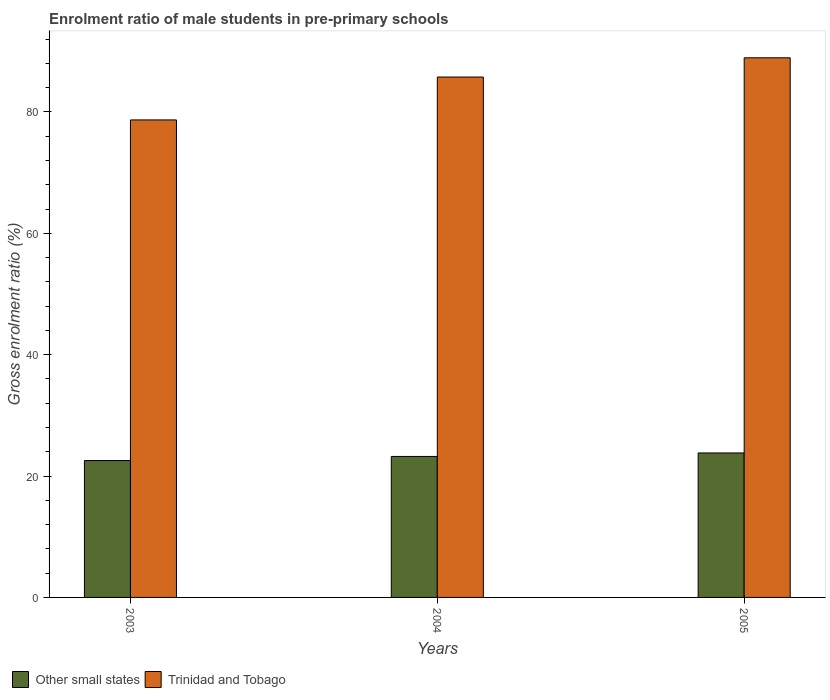How many different coloured bars are there?
Give a very brief answer. 2. Are the number of bars on each tick of the X-axis equal?
Offer a terse response. Yes. How many bars are there on the 2nd tick from the right?
Offer a terse response. 2. What is the label of the 1st group of bars from the left?
Offer a terse response. 2003. In how many cases, is the number of bars for a given year not equal to the number of legend labels?
Your answer should be compact. 0. What is the enrolment ratio of male students in pre-primary schools in Trinidad and Tobago in 2003?
Provide a succinct answer. 78.69. Across all years, what is the maximum enrolment ratio of male students in pre-primary schools in Trinidad and Tobago?
Offer a terse response. 88.92. Across all years, what is the minimum enrolment ratio of male students in pre-primary schools in Trinidad and Tobago?
Make the answer very short. 78.69. In which year was the enrolment ratio of male students in pre-primary schools in Other small states maximum?
Offer a terse response. 2005. What is the total enrolment ratio of male students in pre-primary schools in Other small states in the graph?
Offer a very short reply. 69.6. What is the difference between the enrolment ratio of male students in pre-primary schools in Trinidad and Tobago in 2003 and that in 2005?
Provide a succinct answer. -10.24. What is the difference between the enrolment ratio of male students in pre-primary schools in Trinidad and Tobago in 2003 and the enrolment ratio of male students in pre-primary schools in Other small states in 2005?
Give a very brief answer. 54.88. What is the average enrolment ratio of male students in pre-primary schools in Trinidad and Tobago per year?
Make the answer very short. 84.46. In the year 2005, what is the difference between the enrolment ratio of male students in pre-primary schools in Trinidad and Tobago and enrolment ratio of male students in pre-primary schools in Other small states?
Your answer should be compact. 65.11. What is the ratio of the enrolment ratio of male students in pre-primary schools in Trinidad and Tobago in 2004 to that in 2005?
Your response must be concise. 0.96. What is the difference between the highest and the second highest enrolment ratio of male students in pre-primary schools in Trinidad and Tobago?
Keep it short and to the point. 3.17. What is the difference between the highest and the lowest enrolment ratio of male students in pre-primary schools in Trinidad and Tobago?
Your response must be concise. 10.24. What does the 1st bar from the left in 2003 represents?
Make the answer very short. Other small states. What does the 1st bar from the right in 2005 represents?
Provide a succinct answer. Trinidad and Tobago. Are all the bars in the graph horizontal?
Keep it short and to the point. No. How many years are there in the graph?
Ensure brevity in your answer.  3. Are the values on the major ticks of Y-axis written in scientific E-notation?
Give a very brief answer. No. Does the graph contain any zero values?
Provide a short and direct response. No. Where does the legend appear in the graph?
Provide a succinct answer. Bottom left. What is the title of the graph?
Keep it short and to the point. Enrolment ratio of male students in pre-primary schools. What is the Gross enrolment ratio (%) of Other small states in 2003?
Your answer should be compact. 22.55. What is the Gross enrolment ratio (%) of Trinidad and Tobago in 2003?
Your response must be concise. 78.69. What is the Gross enrolment ratio (%) of Other small states in 2004?
Your response must be concise. 23.23. What is the Gross enrolment ratio (%) in Trinidad and Tobago in 2004?
Your answer should be compact. 85.75. What is the Gross enrolment ratio (%) of Other small states in 2005?
Offer a very short reply. 23.81. What is the Gross enrolment ratio (%) of Trinidad and Tobago in 2005?
Your answer should be compact. 88.92. Across all years, what is the maximum Gross enrolment ratio (%) of Other small states?
Offer a very short reply. 23.81. Across all years, what is the maximum Gross enrolment ratio (%) of Trinidad and Tobago?
Ensure brevity in your answer.  88.92. Across all years, what is the minimum Gross enrolment ratio (%) in Other small states?
Provide a succinct answer. 22.55. Across all years, what is the minimum Gross enrolment ratio (%) in Trinidad and Tobago?
Keep it short and to the point. 78.69. What is the total Gross enrolment ratio (%) in Other small states in the graph?
Give a very brief answer. 69.6. What is the total Gross enrolment ratio (%) in Trinidad and Tobago in the graph?
Provide a succinct answer. 253.37. What is the difference between the Gross enrolment ratio (%) in Other small states in 2003 and that in 2004?
Your response must be concise. -0.68. What is the difference between the Gross enrolment ratio (%) in Trinidad and Tobago in 2003 and that in 2004?
Provide a short and direct response. -7.07. What is the difference between the Gross enrolment ratio (%) in Other small states in 2003 and that in 2005?
Keep it short and to the point. -1.25. What is the difference between the Gross enrolment ratio (%) in Trinidad and Tobago in 2003 and that in 2005?
Make the answer very short. -10.24. What is the difference between the Gross enrolment ratio (%) of Other small states in 2004 and that in 2005?
Offer a terse response. -0.58. What is the difference between the Gross enrolment ratio (%) in Trinidad and Tobago in 2004 and that in 2005?
Offer a very short reply. -3.17. What is the difference between the Gross enrolment ratio (%) in Other small states in 2003 and the Gross enrolment ratio (%) in Trinidad and Tobago in 2004?
Provide a short and direct response. -63.2. What is the difference between the Gross enrolment ratio (%) in Other small states in 2003 and the Gross enrolment ratio (%) in Trinidad and Tobago in 2005?
Your response must be concise. -66.37. What is the difference between the Gross enrolment ratio (%) in Other small states in 2004 and the Gross enrolment ratio (%) in Trinidad and Tobago in 2005?
Give a very brief answer. -65.69. What is the average Gross enrolment ratio (%) in Other small states per year?
Your answer should be compact. 23.2. What is the average Gross enrolment ratio (%) in Trinidad and Tobago per year?
Your answer should be compact. 84.46. In the year 2003, what is the difference between the Gross enrolment ratio (%) in Other small states and Gross enrolment ratio (%) in Trinidad and Tobago?
Your answer should be very brief. -56.13. In the year 2004, what is the difference between the Gross enrolment ratio (%) in Other small states and Gross enrolment ratio (%) in Trinidad and Tobago?
Offer a very short reply. -62.52. In the year 2005, what is the difference between the Gross enrolment ratio (%) in Other small states and Gross enrolment ratio (%) in Trinidad and Tobago?
Offer a very short reply. -65.11. What is the ratio of the Gross enrolment ratio (%) in Other small states in 2003 to that in 2004?
Your response must be concise. 0.97. What is the ratio of the Gross enrolment ratio (%) of Trinidad and Tobago in 2003 to that in 2004?
Ensure brevity in your answer.  0.92. What is the ratio of the Gross enrolment ratio (%) in Other small states in 2003 to that in 2005?
Make the answer very short. 0.95. What is the ratio of the Gross enrolment ratio (%) of Trinidad and Tobago in 2003 to that in 2005?
Offer a very short reply. 0.88. What is the ratio of the Gross enrolment ratio (%) in Other small states in 2004 to that in 2005?
Give a very brief answer. 0.98. What is the difference between the highest and the second highest Gross enrolment ratio (%) in Other small states?
Provide a succinct answer. 0.58. What is the difference between the highest and the second highest Gross enrolment ratio (%) in Trinidad and Tobago?
Offer a very short reply. 3.17. What is the difference between the highest and the lowest Gross enrolment ratio (%) in Other small states?
Your response must be concise. 1.25. What is the difference between the highest and the lowest Gross enrolment ratio (%) of Trinidad and Tobago?
Provide a succinct answer. 10.24. 